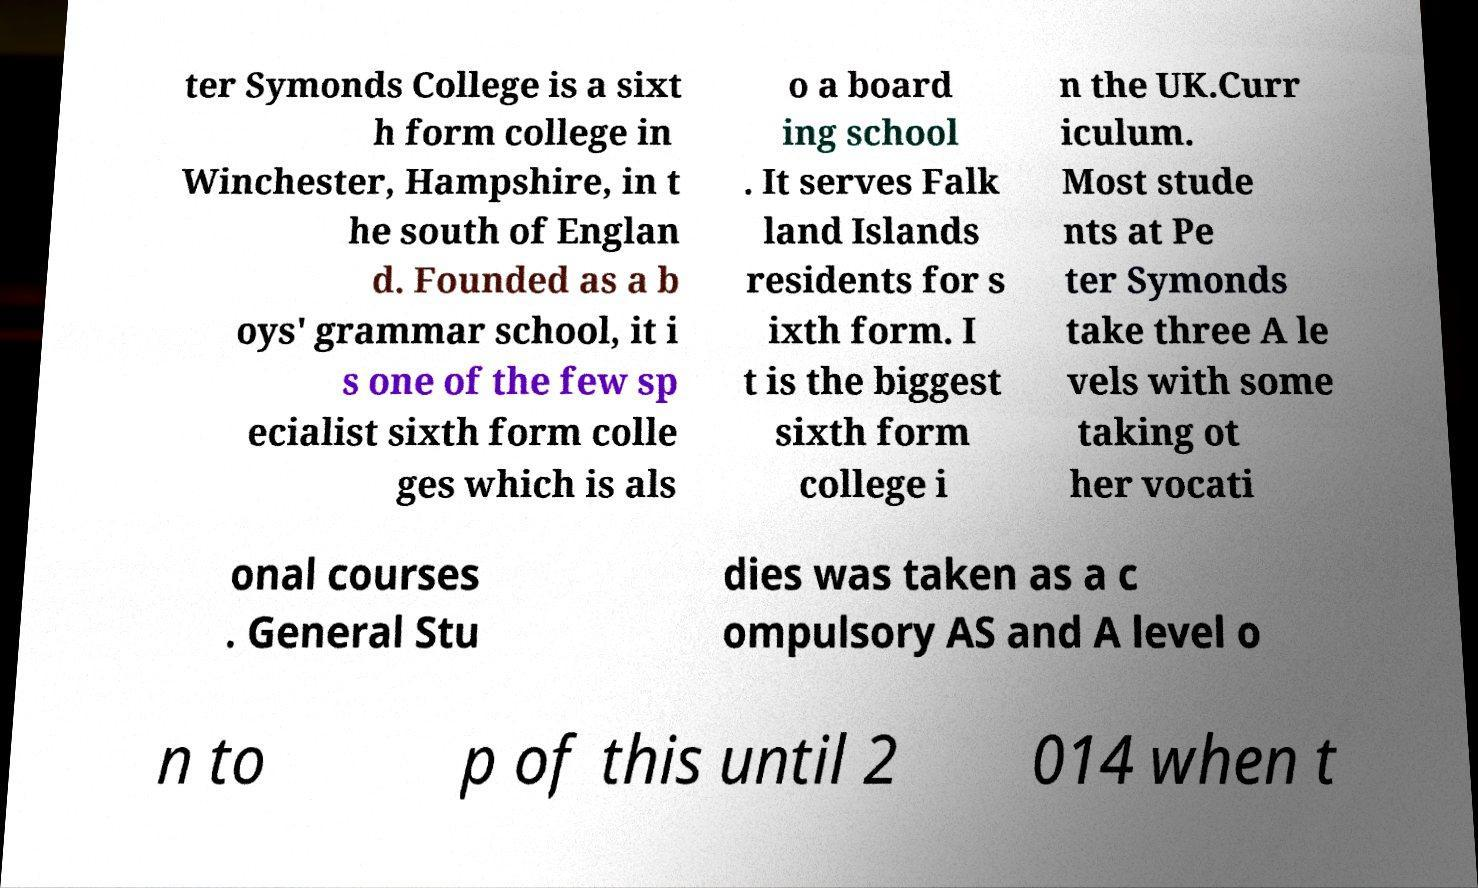Please read and relay the text visible in this image. What does it say? ter Symonds College is a sixt h form college in Winchester, Hampshire, in t he south of Englan d. Founded as a b oys' grammar school, it i s one of the few sp ecialist sixth form colle ges which is als o a board ing school . It serves Falk land Islands residents for s ixth form. I t is the biggest sixth form college i n the UK.Curr iculum. Most stude nts at Pe ter Symonds take three A le vels with some taking ot her vocati onal courses . General Stu dies was taken as a c ompulsory AS and A level o n to p of this until 2 014 when t 